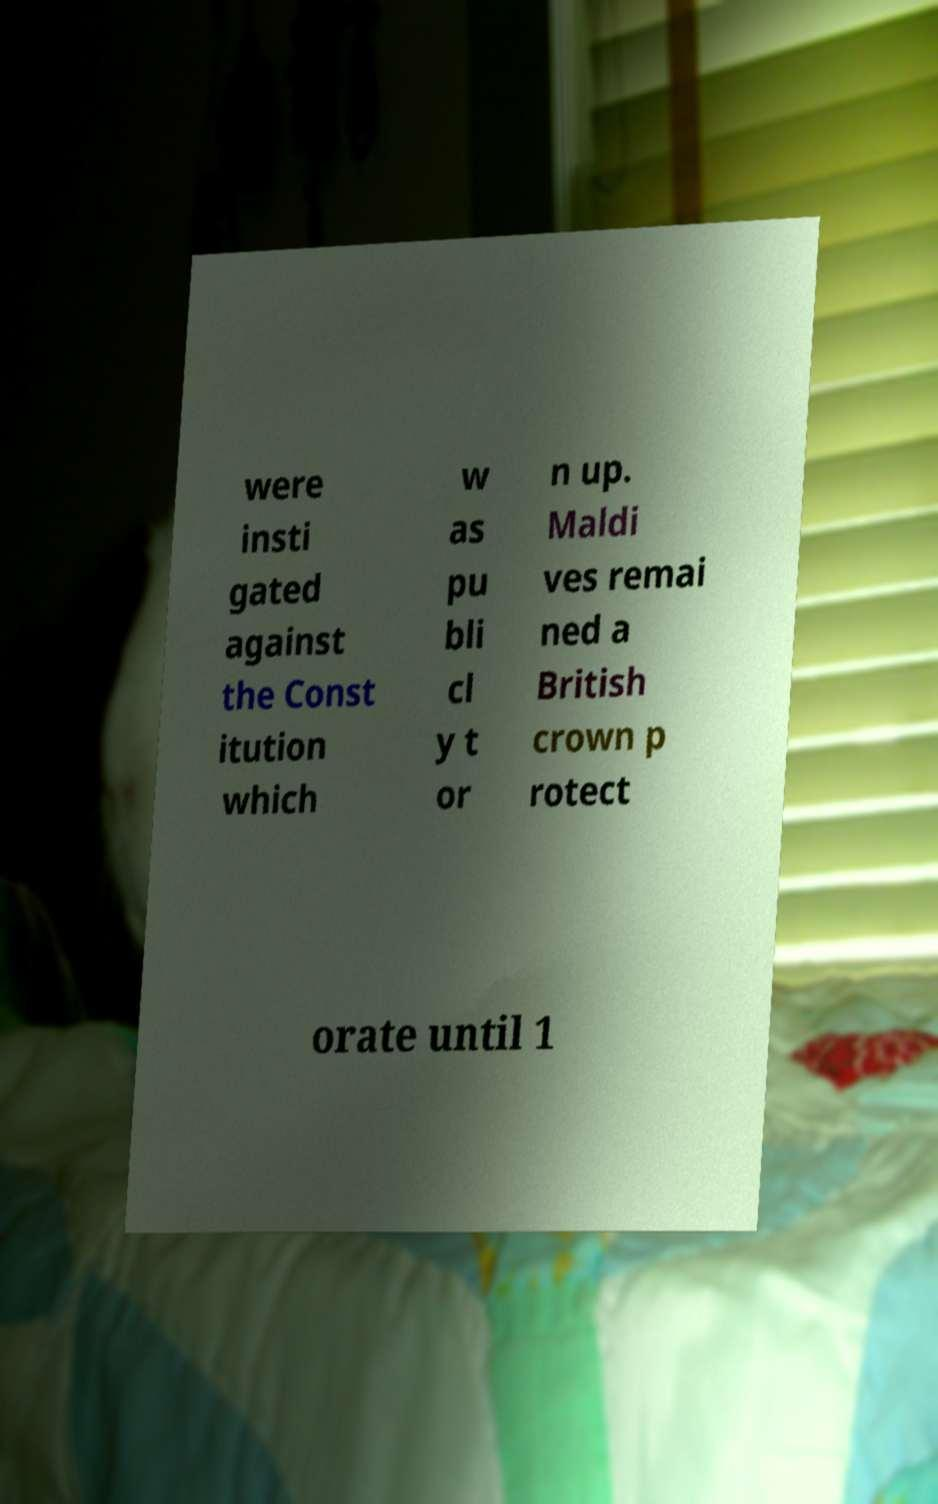Can you read and provide the text displayed in the image?This photo seems to have some interesting text. Can you extract and type it out for me? were insti gated against the Const itution which w as pu bli cl y t or n up. Maldi ves remai ned a British crown p rotect orate until 1 